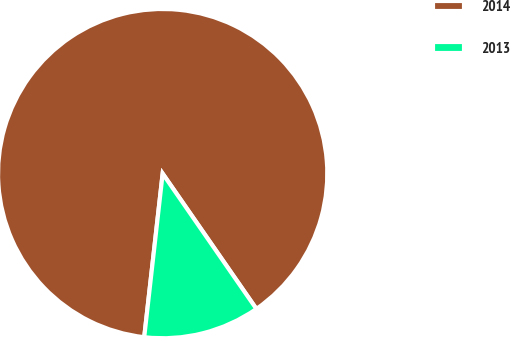Convert chart. <chart><loc_0><loc_0><loc_500><loc_500><pie_chart><fcel>2014<fcel>2013<nl><fcel>88.57%<fcel>11.43%<nl></chart> 